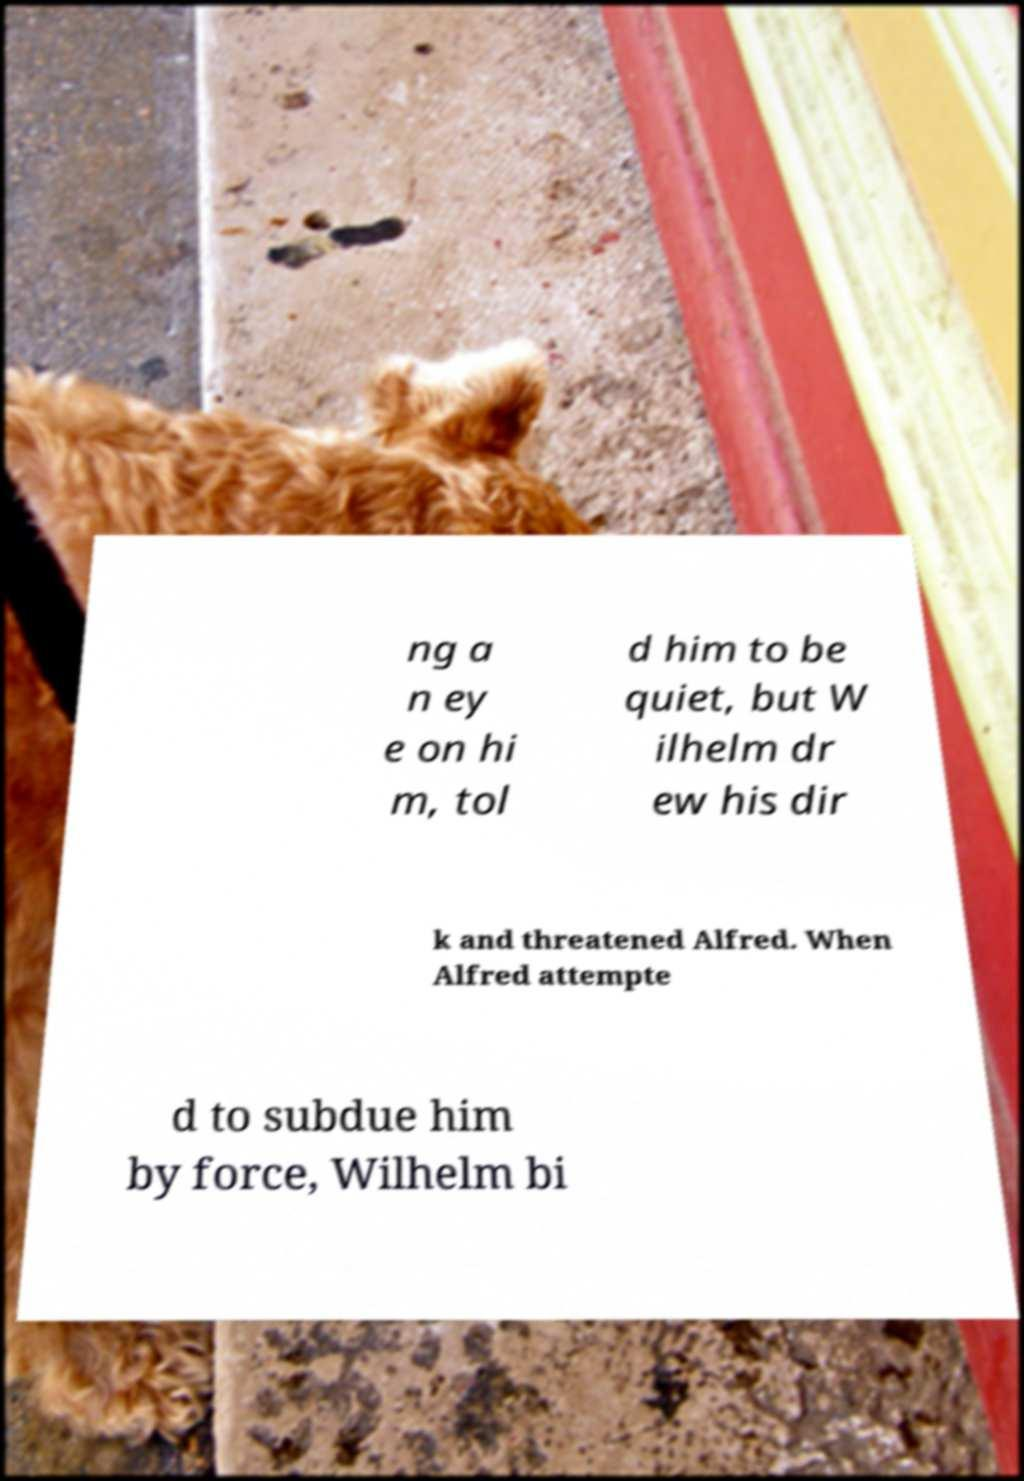Please read and relay the text visible in this image. What does it say? ng a n ey e on hi m, tol d him to be quiet, but W ilhelm dr ew his dir k and threatened Alfred. When Alfred attempte d to subdue him by force, Wilhelm bi 